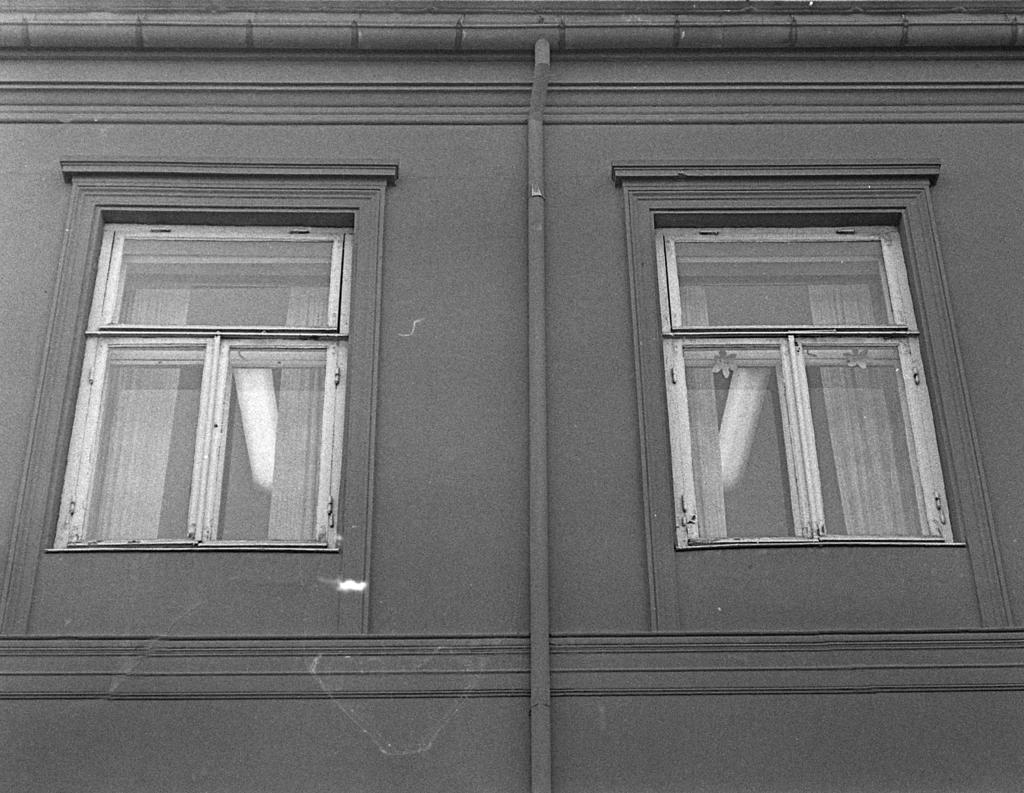What is the color scheme of the image? The image is black and white. What is the main subject in the image? There is a building in the image. How many windows can be seen on the building? The building has two windows. Where is the map located in the image? There is no map present in the image. What type of screw is holding the building together in the image? There is no screw visible in the image, and the building's construction is not mentioned in the provided facts. 